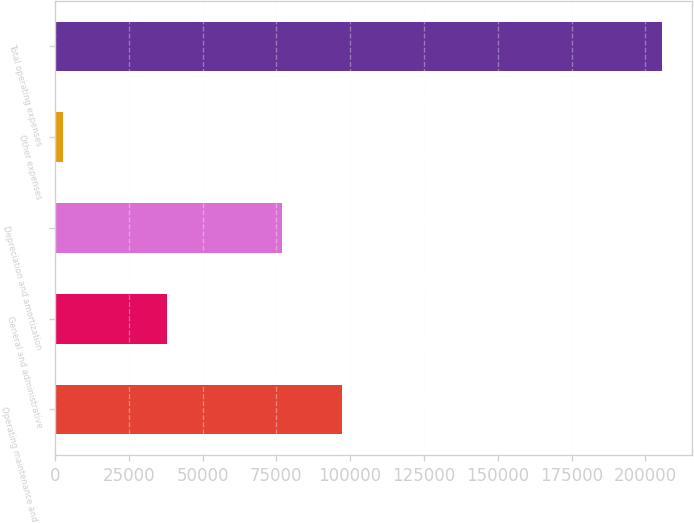<chart> <loc_0><loc_0><loc_500><loc_500><bar_chart><fcel>Operating maintenance and real<fcel>General and administrative<fcel>Depreciation and amortization<fcel>Other expenses<fcel>Total operating expenses<nl><fcel>97205.2<fcel>37815<fcel>76925<fcel>2758<fcel>205560<nl></chart> 